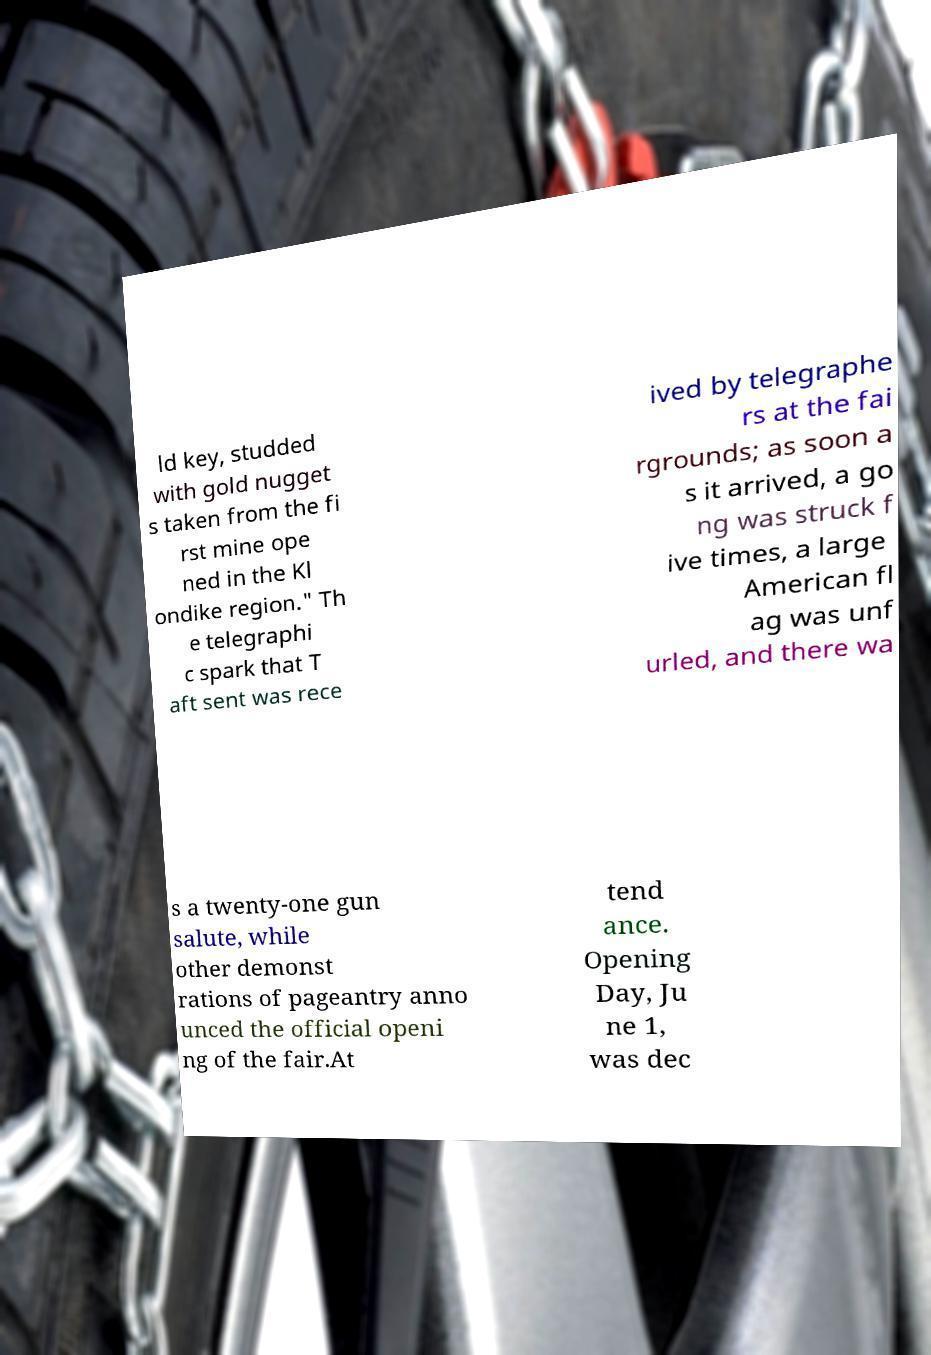For documentation purposes, I need the text within this image transcribed. Could you provide that? ld key, studded with gold nugget s taken from the fi rst mine ope ned in the Kl ondike region." Th e telegraphi c spark that T aft sent was rece ived by telegraphe rs at the fai rgrounds; as soon a s it arrived, a go ng was struck f ive times, a large American fl ag was unf urled, and there wa s a twenty-one gun salute, while other demonst rations of pageantry anno unced the official openi ng of the fair.At tend ance. Opening Day, Ju ne 1, was dec 